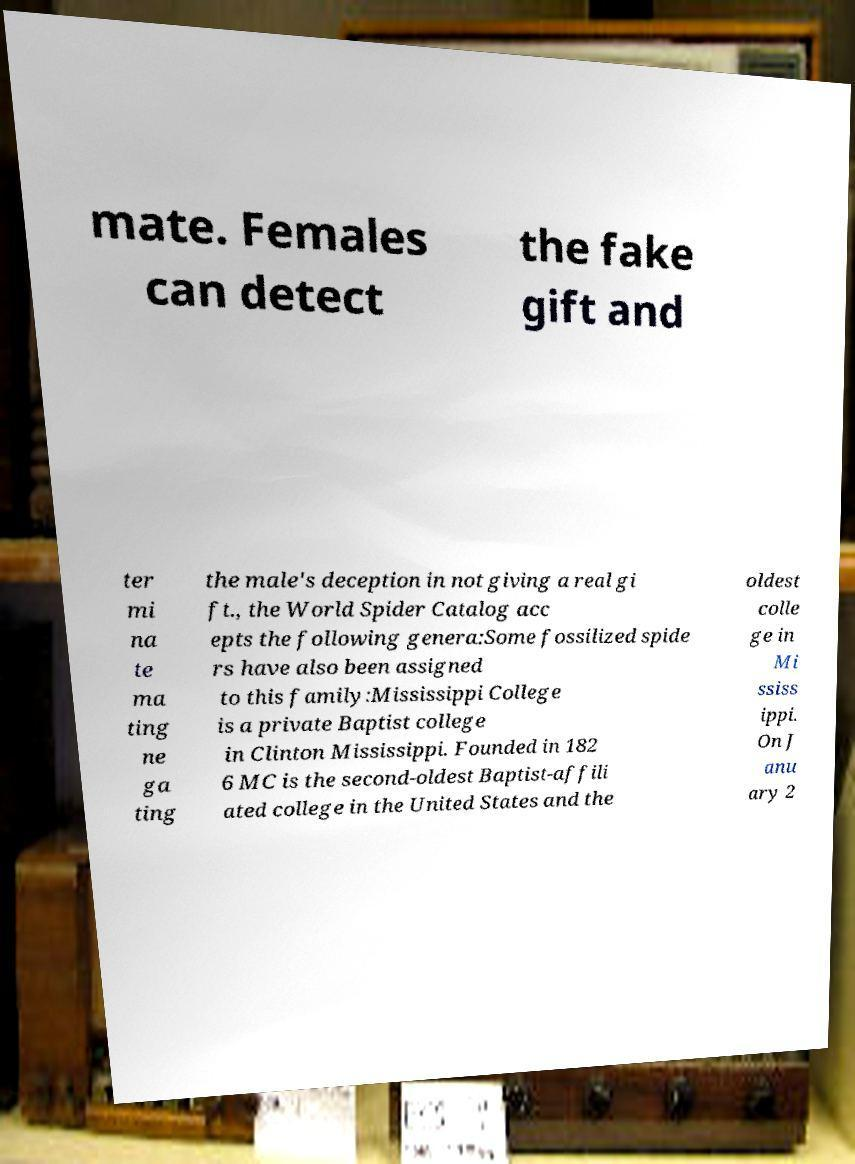I need the written content from this picture converted into text. Can you do that? mate. Females can detect the fake gift and ter mi na te ma ting ne ga ting the male's deception in not giving a real gi ft., the World Spider Catalog acc epts the following genera:Some fossilized spide rs have also been assigned to this family:Mississippi College is a private Baptist college in Clinton Mississippi. Founded in 182 6 MC is the second-oldest Baptist-affili ated college in the United States and the oldest colle ge in Mi ssiss ippi. On J anu ary 2 